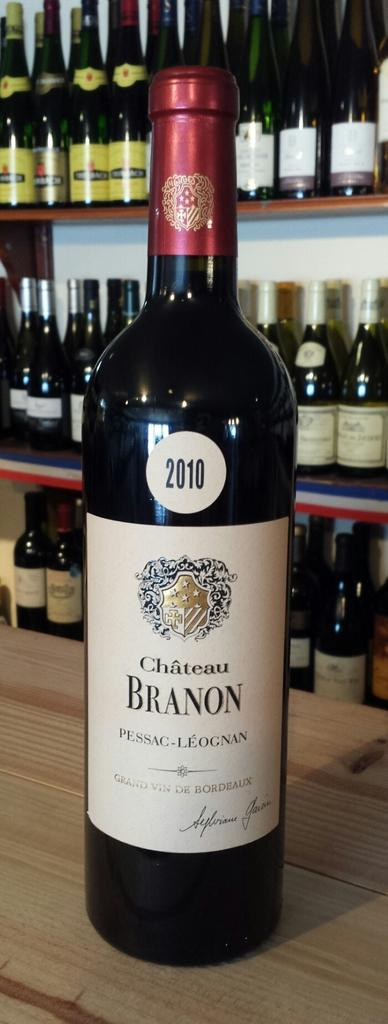<image>
Create a compact narrative representing the image presented. A bottle of 2010 Chateau Branon sits on a wood bar. 